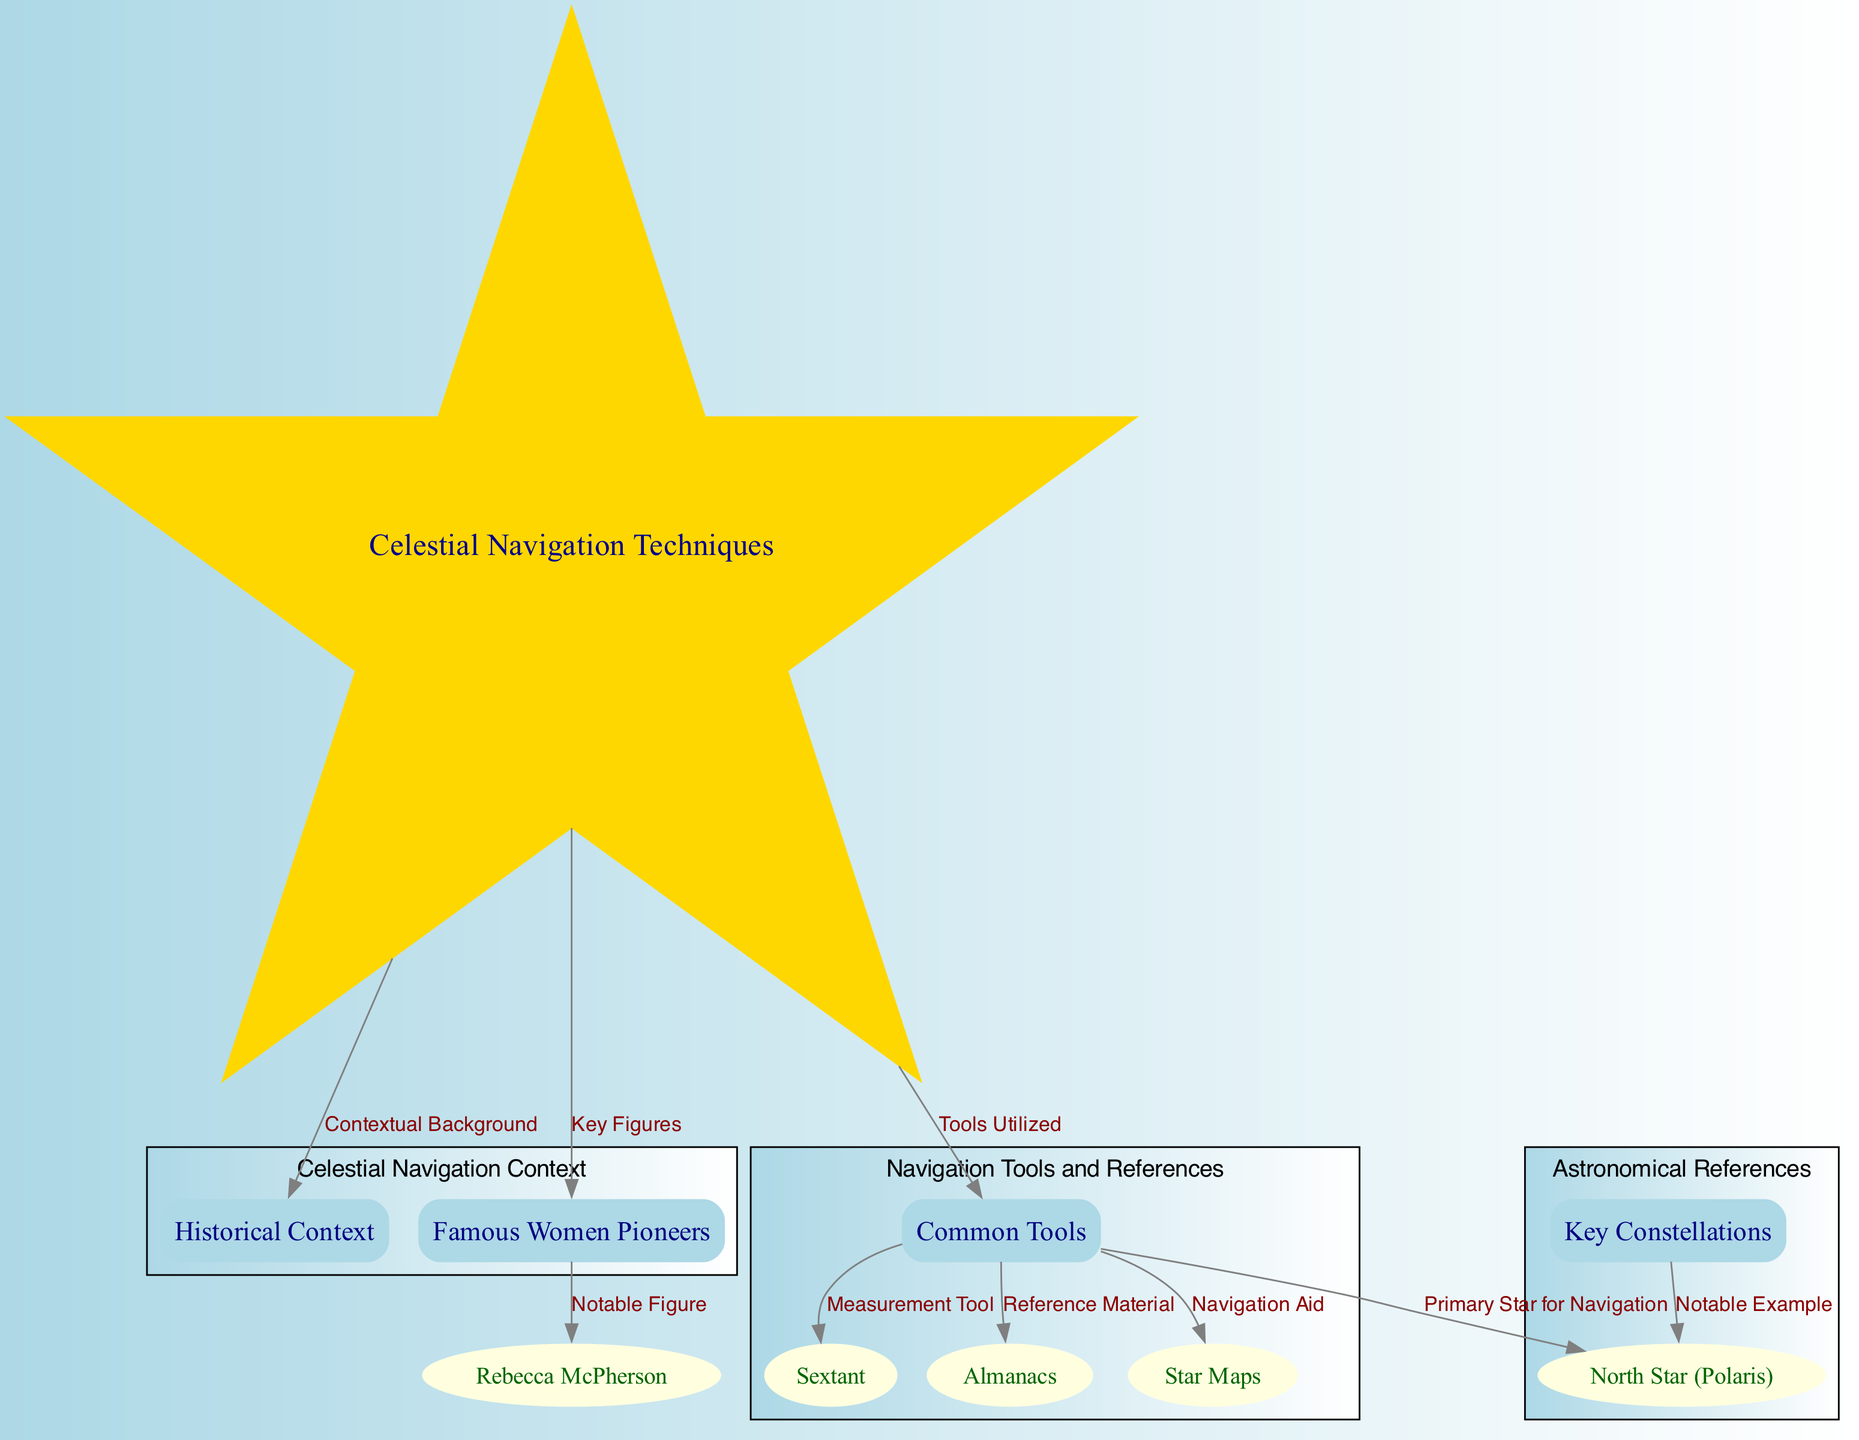What are the main categories of celestial navigation highlighted in the diagram? The diagram features three main categories connected to celestial navigation: Historical Context, Common Tools, and Famous Women Pioneers. These categories encapsulate different aspects of the navigation techniques used by women pioneers.
Answer: Historical Context, Common Tools, Famous Women Pioneers Which primary star is focused on for navigation in the diagram? The diagram specifies the North Star (Polaris) as the primary star for navigation, connecting it to both the navigation tools and the key constellations used by pioneers.
Answer: North Star (Polaris) How many tools are listed under the Common Tools category? There are four tools mentioned under the Common Tools category: Sextant, Almanacs, and Star Maps. Hence, the total count of tools is three.
Answer: Three Who is identified as a notable figure among the Famous Women Pioneers? Rebecca McPherson is noted in the diagram as a notable figure linked under the Famous Women Pioneers category, explicitly connecting her to the context of women navigating in the Wild West.
Answer: Rebecca McPherson What is the relationship between Common Tools and Reference Material? The diagram shows that Common Tools is directly linked to Reference Material through an edge labeled "Reference Material," indicating that these tools, like Almanacs and Star Maps, served as essential references for navigation.
Answer: Reference Material Which tools are indicated as Navigation Aids in the diagram? The diagram lists Star Maps as a Navigation Aid. This is part of the Common Tools category, which highlights how these aids assisted women pioneers in their navigation efforts.
Answer: Star Maps What role does the North Star (Polaris) play according to the connections shown in the diagram? The North Star (Polaris) is depicted as the Primary Star for Navigation, illustrating its importance and centrality in celestial navigation practices among the women pioneers during the 19th century.
Answer: Primary Star for Navigation How many edges are shown connecting from the Common Tools node? There are four edges connecting from the Common Tools node to other nodes, indicating the various tools and their uses in celestial navigation.
Answer: Four 